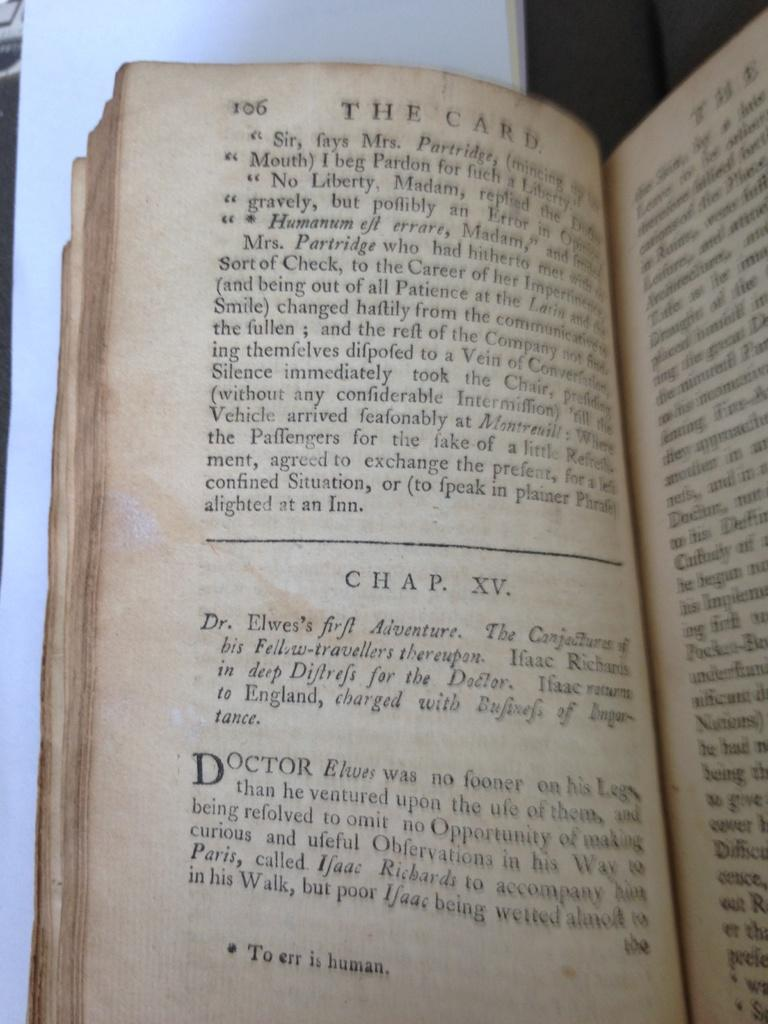What object is present in the image? There is a book in the image. What is a notable feature of the book? The book has pages. What can be found on the pages of the book? There is writing on the pages of the book. How many chickens are visible on the pages of the book? There are no chickens present on the pages of the book; the pages contain writing. 